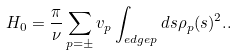Convert formula to latex. <formula><loc_0><loc_0><loc_500><loc_500>H _ { 0 } = \frac { \pi } { \nu } \sum _ { p = \pm } v _ { p } \int _ { e d g e p } d s \rho _ { p } ( s ) ^ { 2 } . .</formula> 